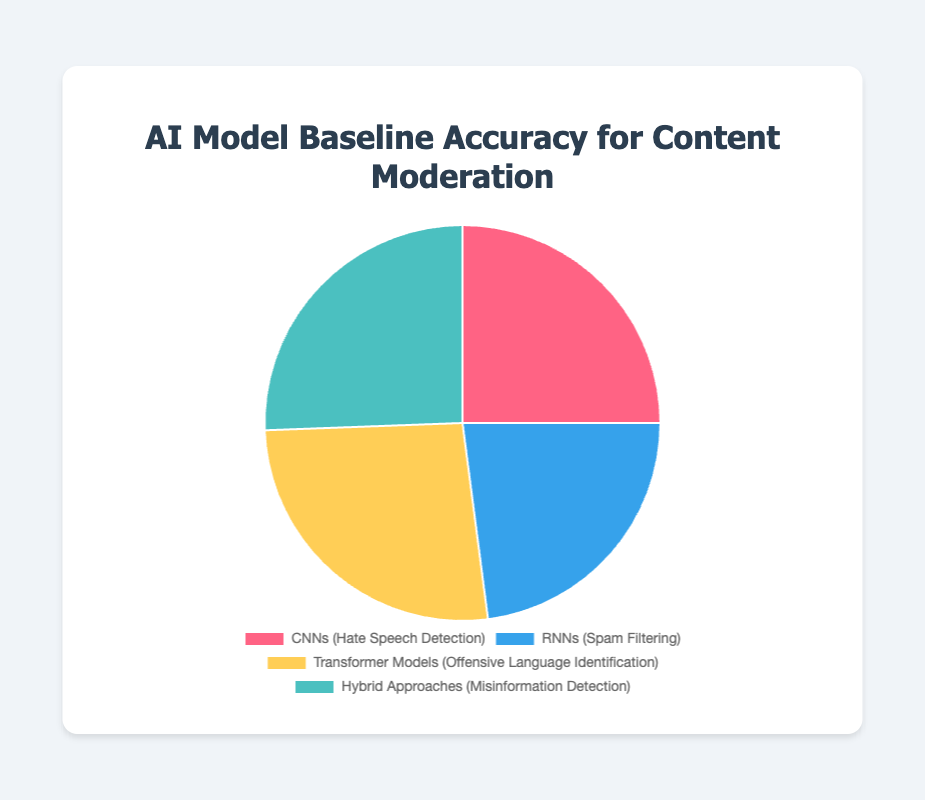Which AI model has the highest baseline accuracy for content moderation? By looking at the pie chart, the largest segment represents the model with the highest baseline accuracy. The label associated with that segment is "Transformer Models (Offensive Language Identification)" with an accuracy of 90%.
Answer: Transformer Models Which model has the lowest baseline accuracy, and what is its value? To identify the model with the lowest baseline accuracy, look for the smallest segment in the pie chart, which corresponds to "Recurrent Neural Networks (Spam Filtering)" with an accuracy of 78%.
Answer: Recurrent Neural Networks, 78% What is the average baseline accuracy of all the models presented? First, sum up all the baseline accuracies: 85 (CNNs) + 78 (RNNs) + 90 (Transformers) + 87 (Hybrid) = 340. Then divide by the number of models, which is 4. So, the average baseline accuracy is 340/4 = 85.
Answer: 85 How much higher is the baseline accuracy of Hybrid Approaches compared to Recurrent Neural Networks? Subtract the baseline accuracy of RNNs from Hybrid Approaches: 87 (Hybrid) - 78 (RNNs) = 9.
Answer: 9 Which models have a baseline accuracy above 85%? Models with baseline accuracy above 85% are identified by segments whose accuracy value is greater than 85%. These models are "Transformer Models (90%)" and "Hybrid Approaches (87%)".
Answer: Transformer Models and Hybrid Approaches What is the total combined baseline accuracy for Convolutional Neural Networks and Transformer Models? Sum up the baseline accuracies for CNNs and Transformers: 85 (CNNs) + 90 (Transformers) = 175.
Answer: 175 How does the baseline accuracy of CNNs compare visually to the baseline accuracy of RNNs? Visually, the segment representing CNNs is larger than the segment representing RNNs, indicating that CNNs have a higher baseline accuracy. Specifically, CNNs have an accuracy of 85%, while RNNs have an accuracy of 78%.
Answer: CNNs have higher accuracy What percentage of the total baseline accuracy is contributed by Hybrid Approaches? Calculate the percentage by taking the baseline accuracy of Hybrid Approaches and dividing it by the total sum, then multiplying by 100. The total sum is 340. So, (87/340) * 100 = 25.59%.
Answer: 25.59% Which color represents the Transformer Models in the pie chart, and what is their associated task? The color representing Transformer Models should be identified visually from the chart. The label "Transformer Models (Offensive Language Identification)" is associated with that segment, which is yellow.
Answer: Yellow, Offensive Language Identification What is the difference between the highest and lowest baseline accuracy among the models? Subtract the lowest baseline accuracy from the highest baseline accuracy: 90 (highest, Transformers) - 78 (lowest, RNNs) = 12.
Answer: 12 